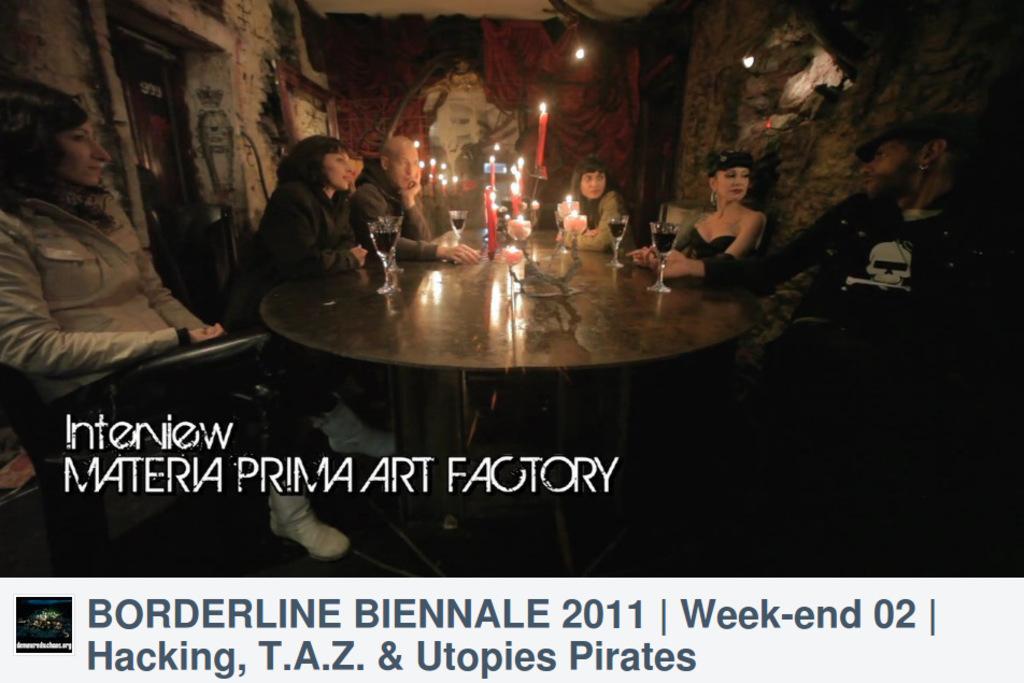In one or two sentences, can you explain what this image depicts? In this picture we can see some persons are sitting on the chairs. This is table. On the table there are glasses and these are the candles. On the background there is a wall. 